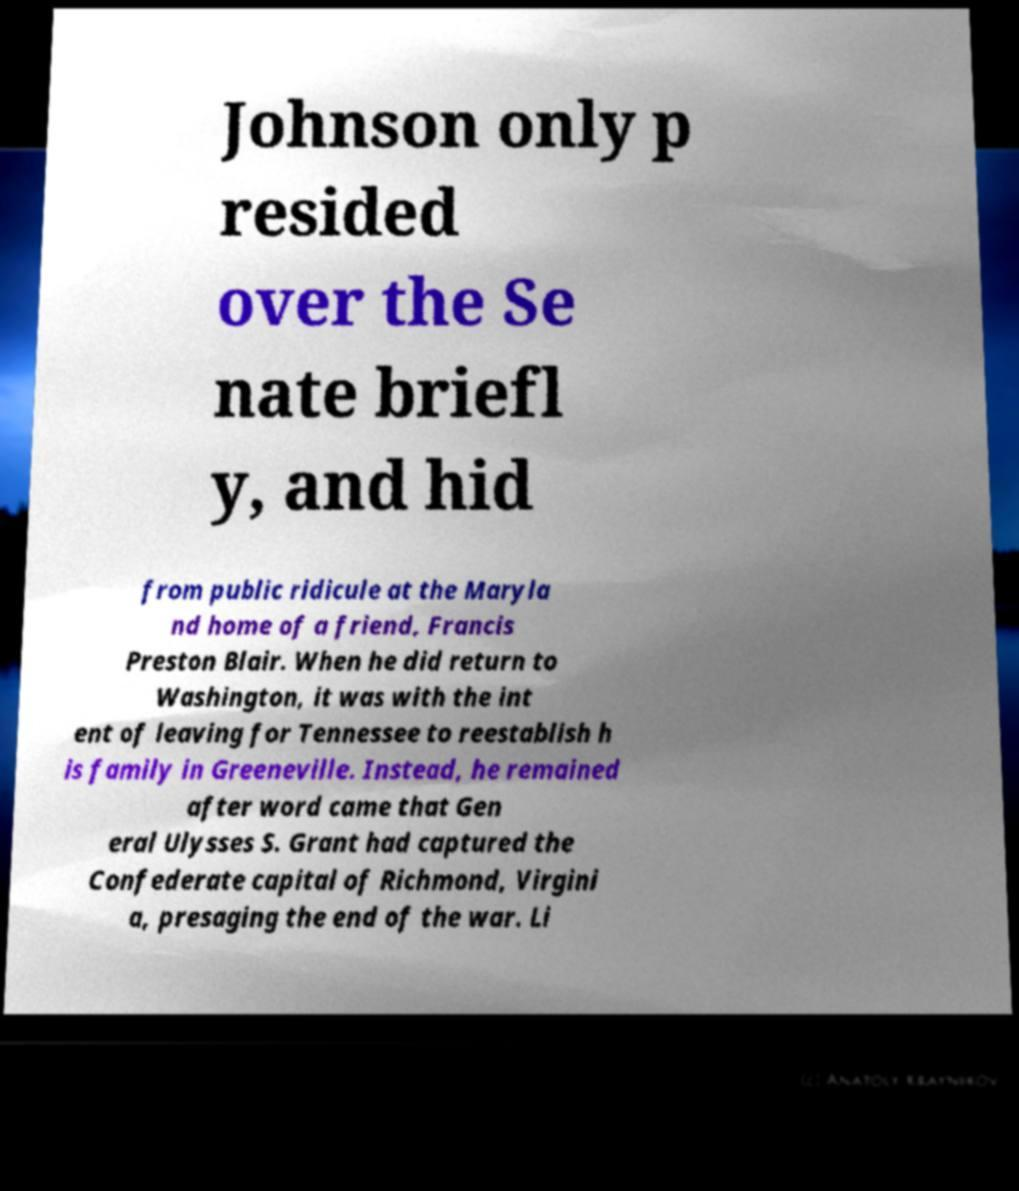Please identify and transcribe the text found in this image. Johnson only p resided over the Se nate briefl y, and hid from public ridicule at the Maryla nd home of a friend, Francis Preston Blair. When he did return to Washington, it was with the int ent of leaving for Tennessee to reestablish h is family in Greeneville. Instead, he remained after word came that Gen eral Ulysses S. Grant had captured the Confederate capital of Richmond, Virgini a, presaging the end of the war. Li 